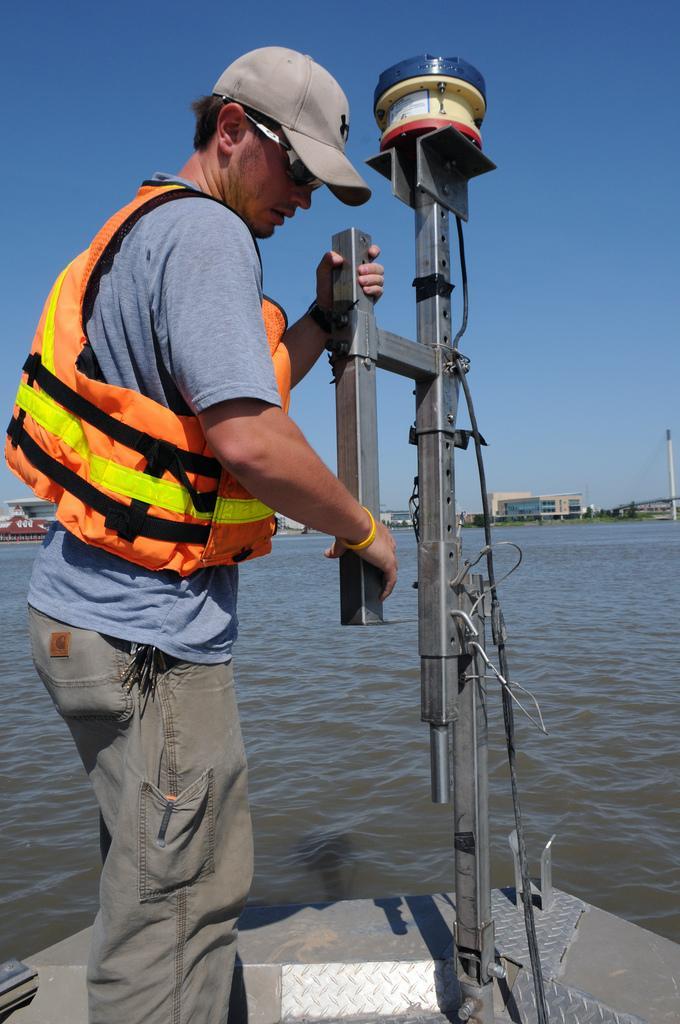Please provide a concise description of this image. In this image we can see a man standing on the boat. In the background there is water and we can see buildings. At the top there is sky. 